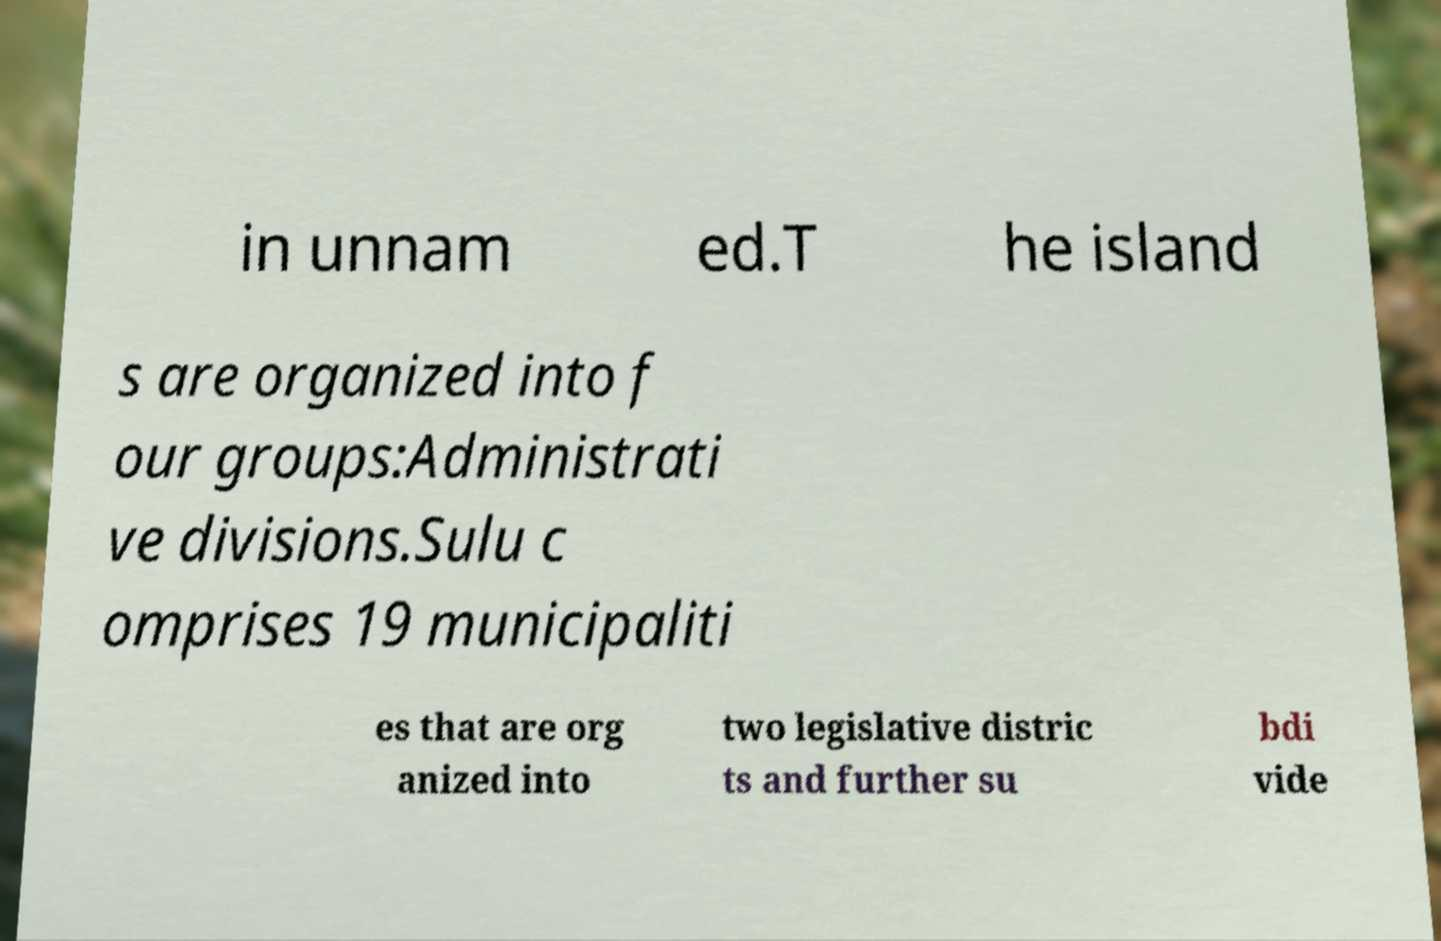Could you extract and type out the text from this image? in unnam ed.T he island s are organized into f our groups:Administrati ve divisions.Sulu c omprises 19 municipaliti es that are org anized into two legislative distric ts and further su bdi vide 